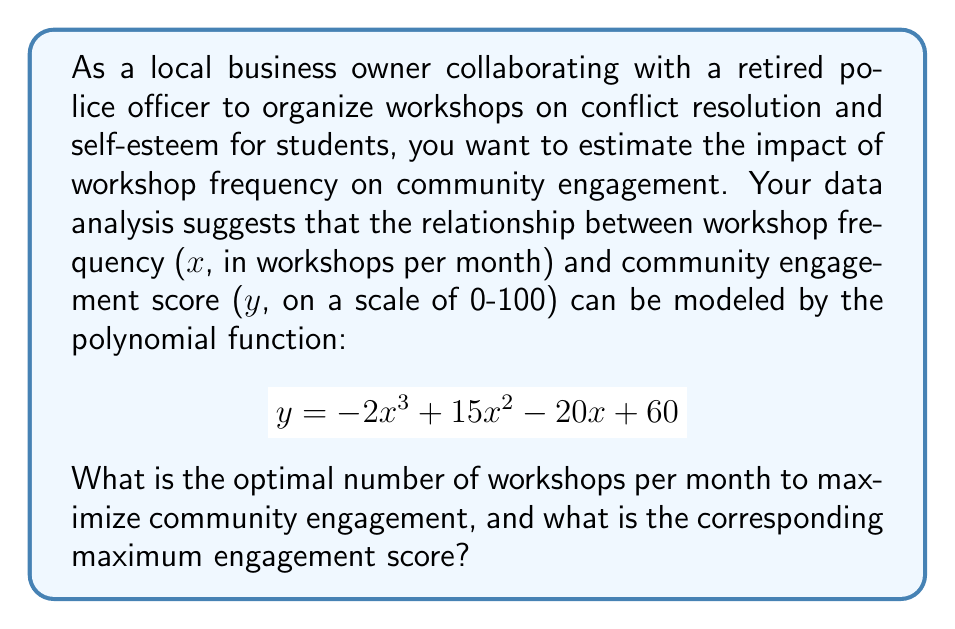Provide a solution to this math problem. To find the optimal number of workshops and the maximum engagement score, we need to follow these steps:

1) The maximum point of the function will occur where its derivative equals zero. Let's find the derivative:

   $$\frac{dy}{dx} = -6x^2 + 30x - 20$$

2) Set the derivative equal to zero and solve for x:

   $$-6x^2 + 30x - 20 = 0$$

3) This is a quadratic equation. We can solve it using the quadratic formula:
   $$x = \frac{-b \pm \sqrt{b^2 - 4ac}}{2a}$$

   Where $a = -6$, $b = 30$, and $c = -20$

4) Plugging in these values:

   $$x = \frac{-30 \pm \sqrt{30^2 - 4(-6)(-20)}}{2(-6)}$$
   $$= \frac{-30 \pm \sqrt{900 - 480}}{-12}$$
   $$= \frac{-30 \pm \sqrt{420}}{-12}$$

5) Simplifying:

   $$x = \frac{-30 \pm 20.494}{-12}$$

6) This gives us two solutions:
   $$x_1 = \frac{-30 + 20.494}{-12} \approx 0.792$$
   $$x_2 = \frac{-30 - 20.494}{-12} \approx 4.208$$

7) The second derivative is $-12x + 30$, which is negative when $x > 2.5$. Therefore, $x_2 \approx 4.208$ gives us the maximum point.

8) To find the maximum engagement score, we plug this x-value back into the original function:

   $$y = -2(4.208)^3 + 15(4.208)^2 - 20(4.208) + 60$$
   $$\approx 91.02$$

Therefore, the optimal number of workshops is approximately 4.21 per month, resulting in a maximum engagement score of about 91.02.
Answer: 4.21 workshops/month; 91.02 engagement score 